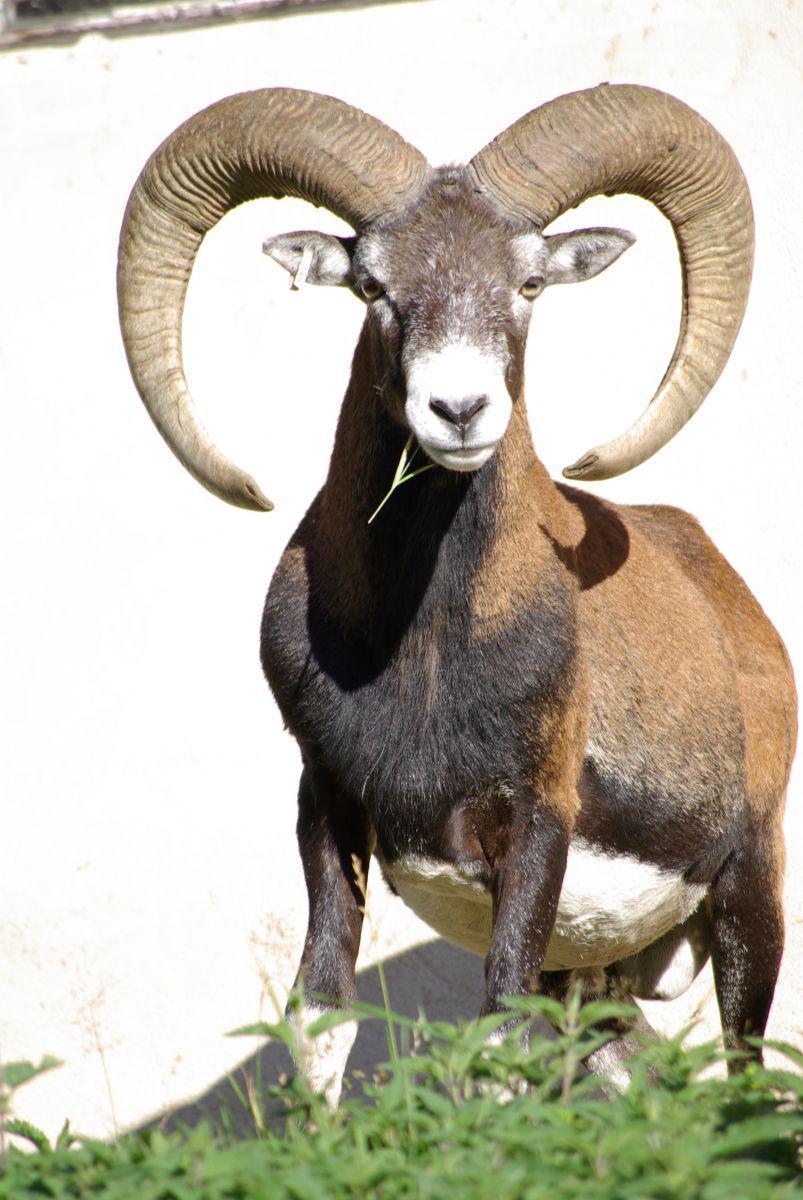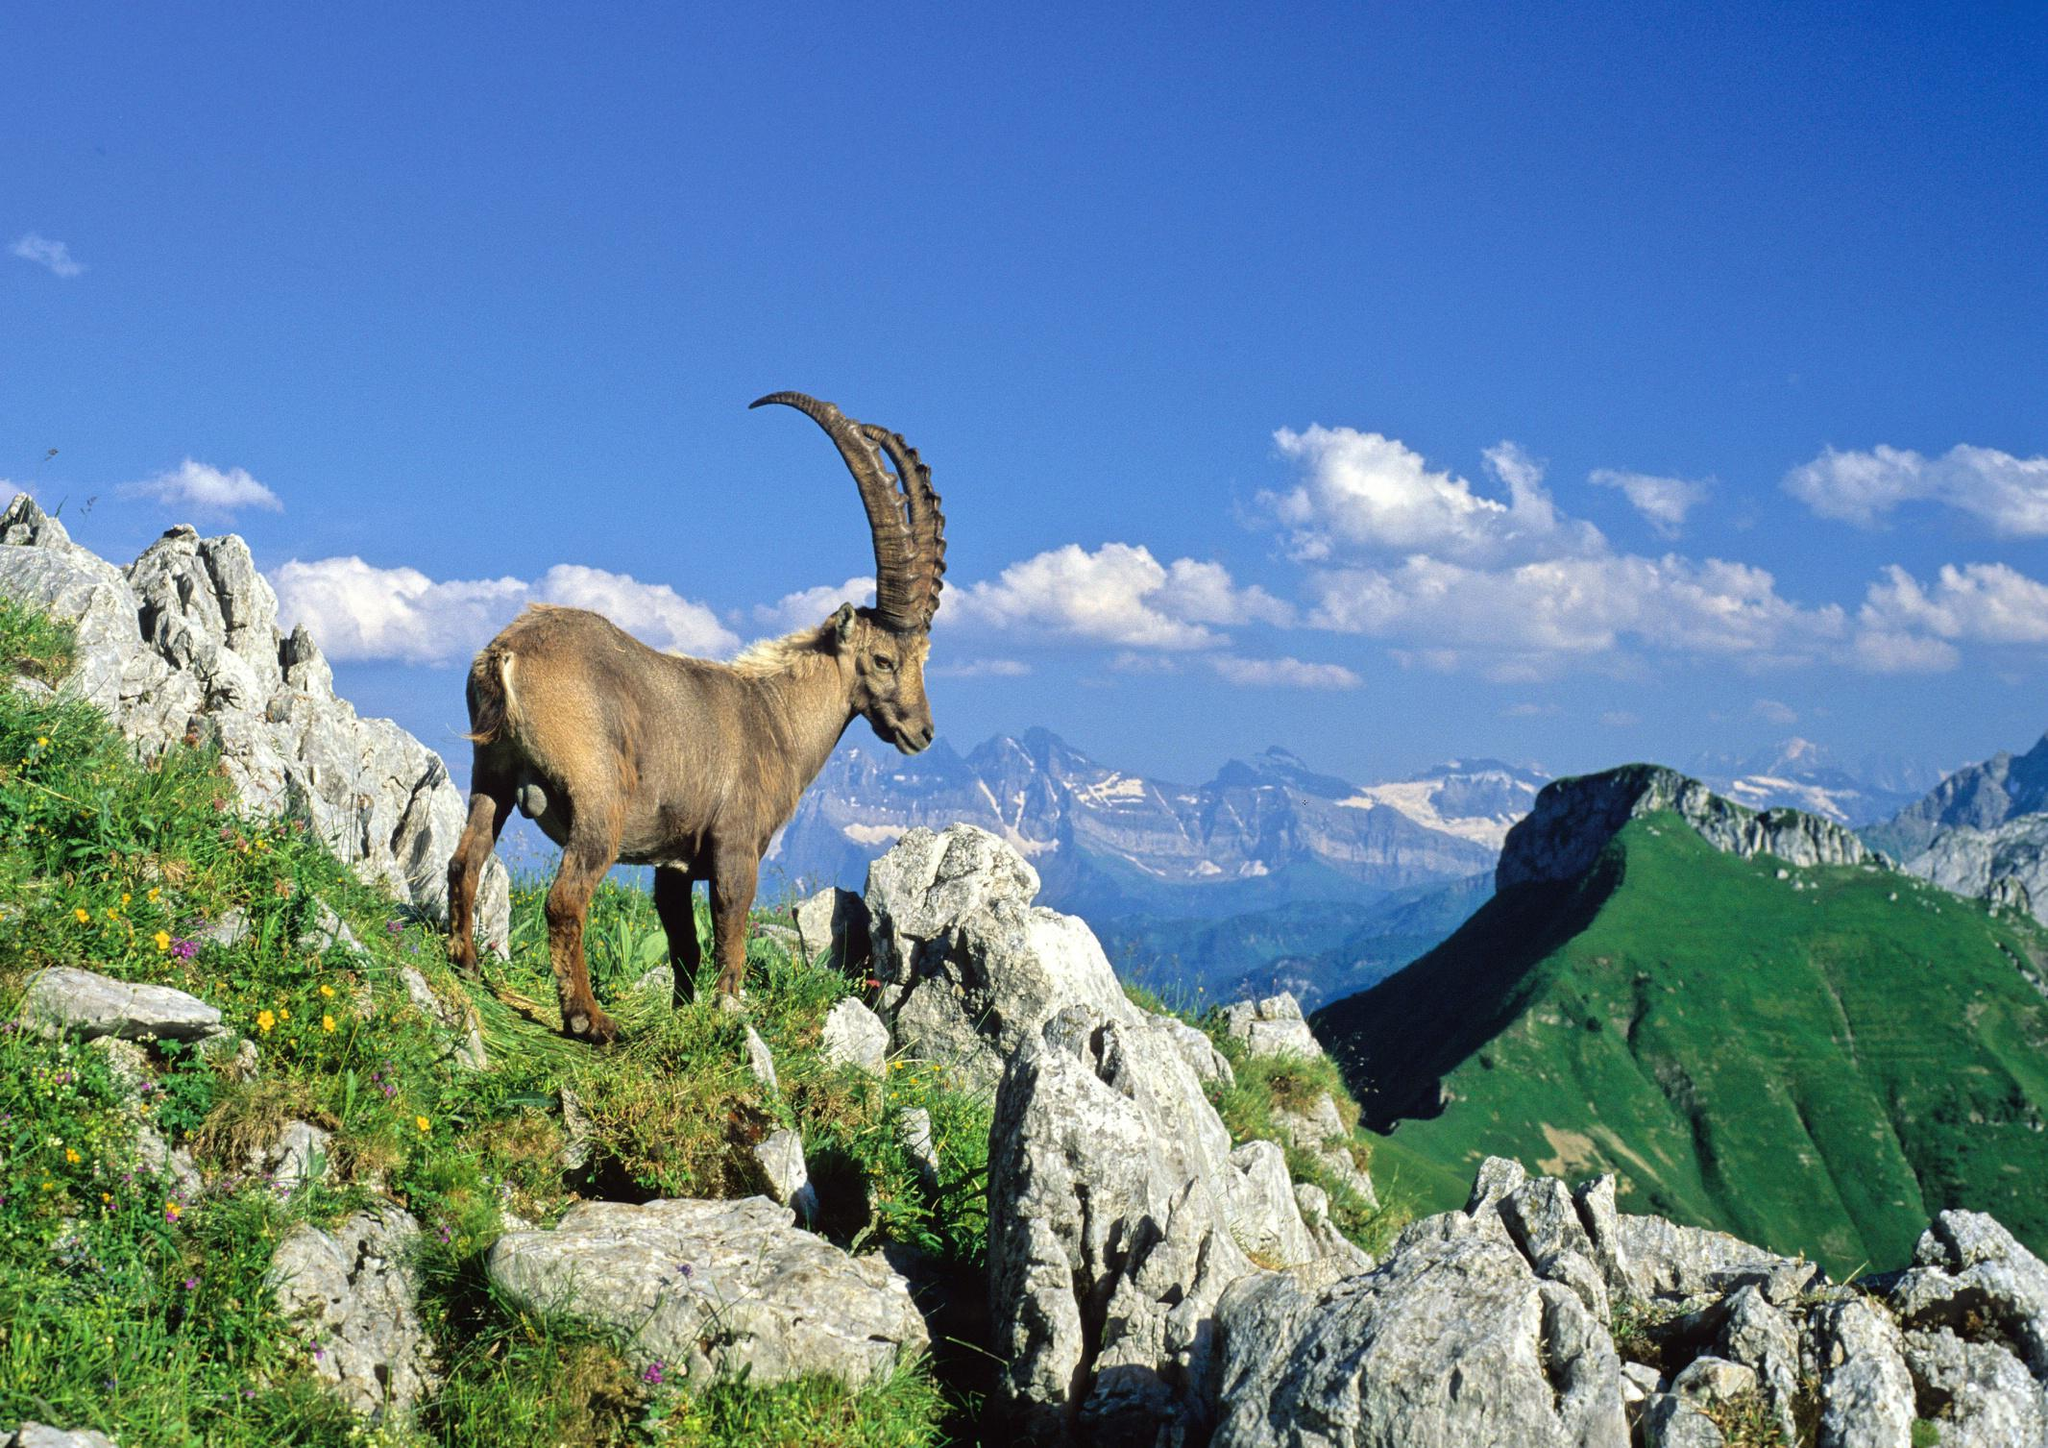The first image is the image on the left, the second image is the image on the right. For the images shown, is this caption "There is at least 1 goat standing among plants." true? Answer yes or no. Yes. 